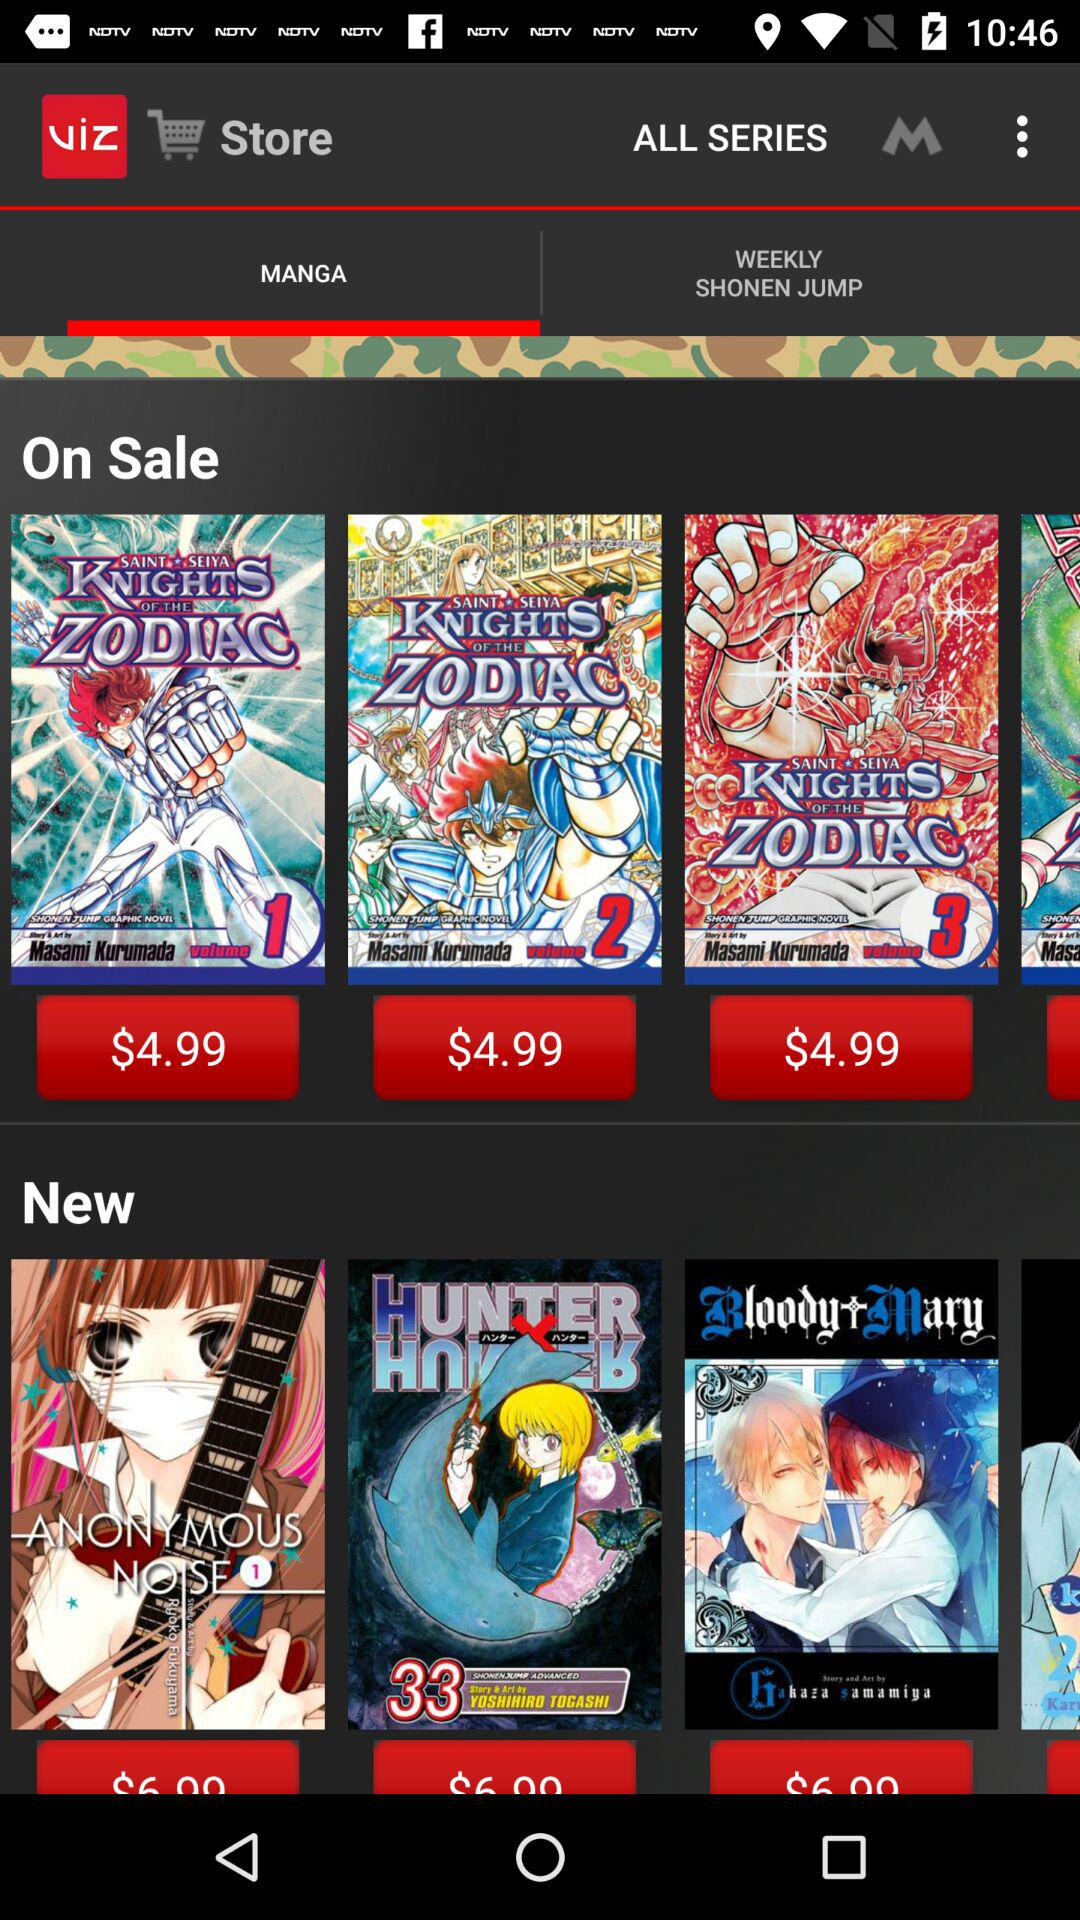What is the currency used for the prices of the series books? The used currency is dollars. 